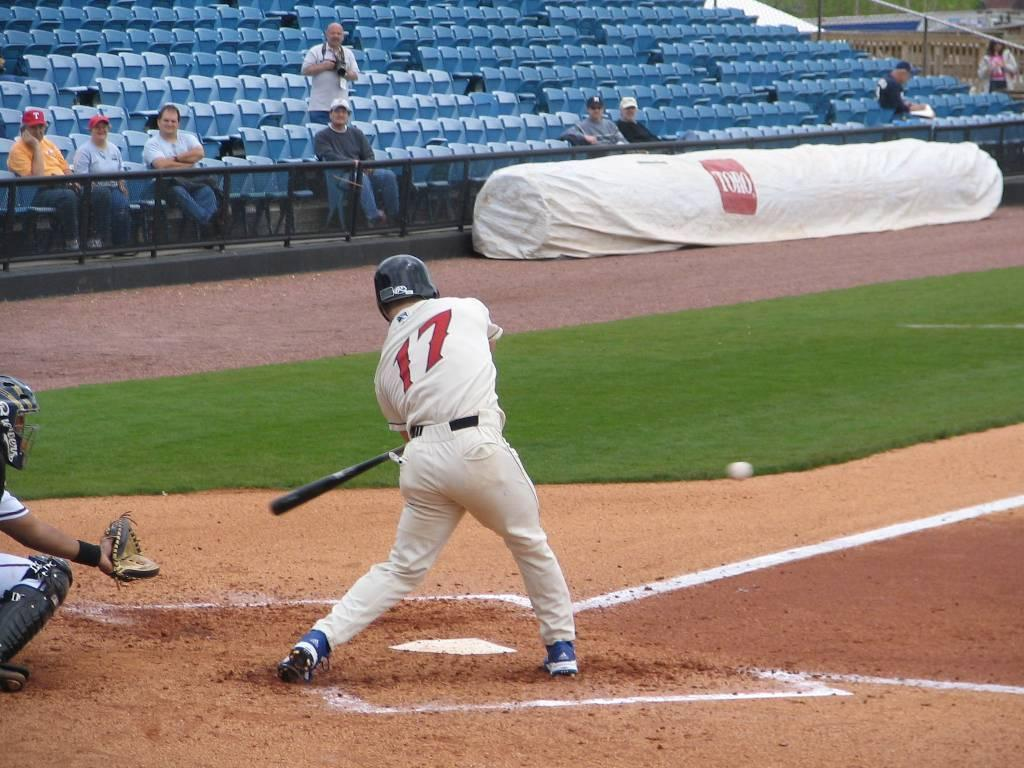<image>
Present a compact description of the photo's key features. A baseball player in a #17 white jersey bats in front of blue seats and a Toro logo 